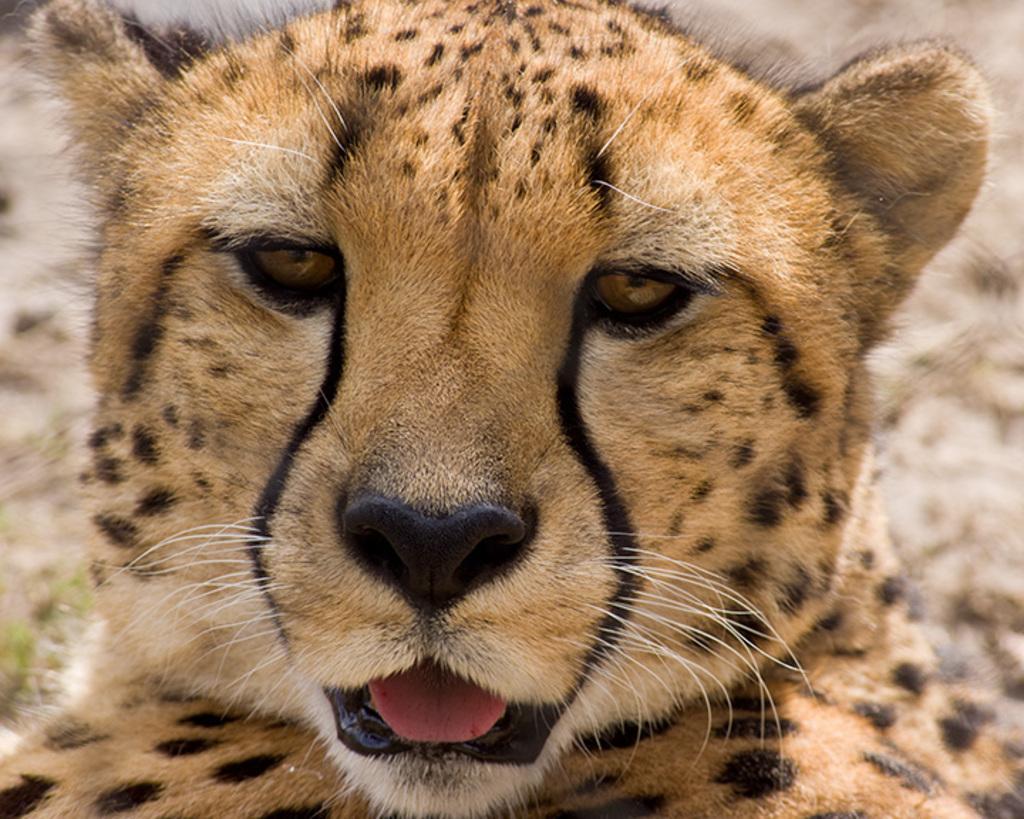Describe this image in one or two sentences. In this image we can see a cheetah. 